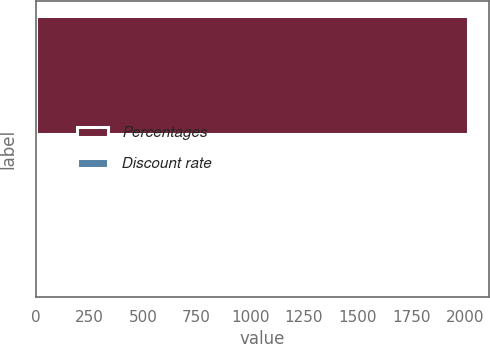Convert chart. <chart><loc_0><loc_0><loc_500><loc_500><bar_chart><fcel>Percentages<fcel>Discount rate<nl><fcel>2014<fcel>3.94<nl></chart> 